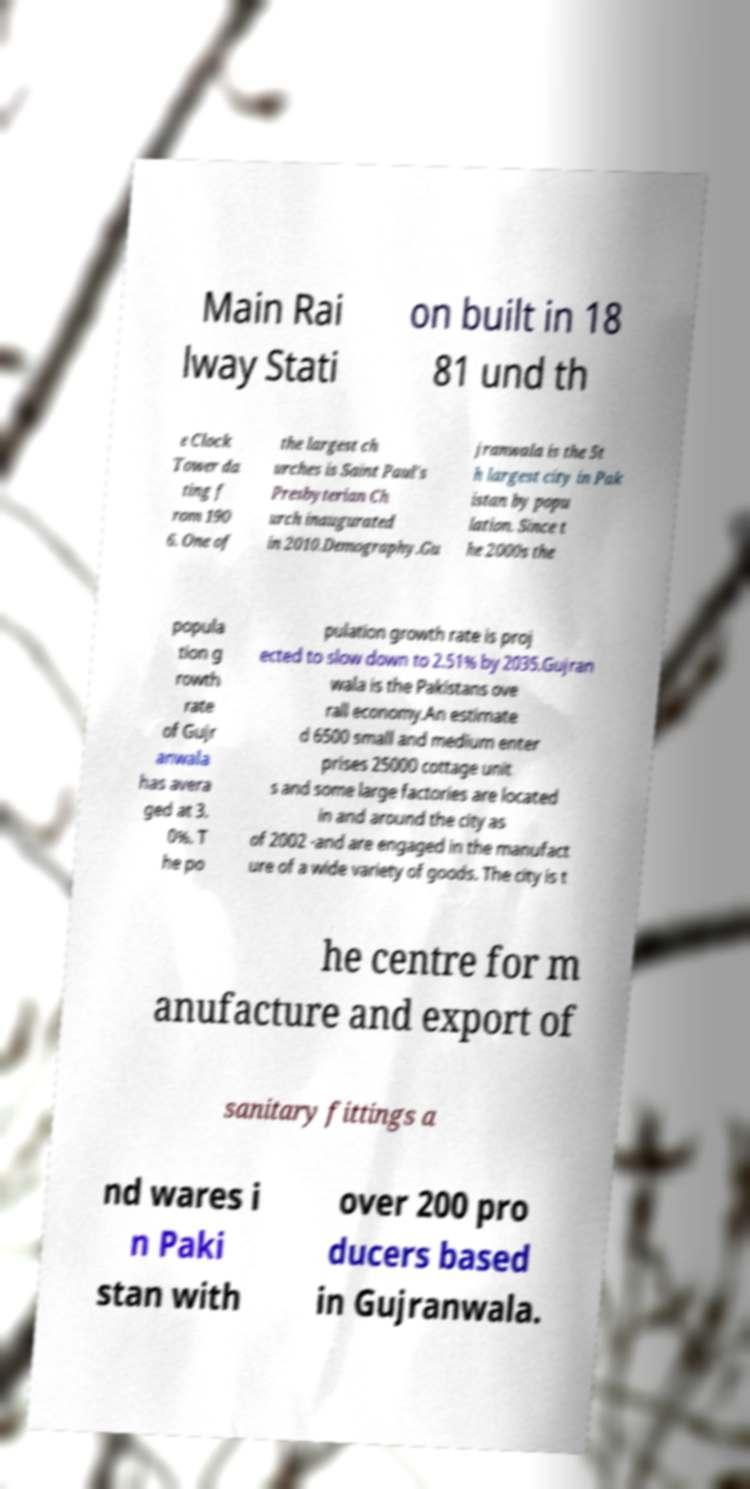Please read and relay the text visible in this image. What does it say? Main Rai lway Stati on built in 18 81 und th e Clock Tower da ting f rom 190 6. One of the largest ch urches is Saint Paul's Presbyterian Ch urch inaugurated in 2010.Demography.Gu jranwala is the 5t h largest city in Pak istan by popu lation. Since t he 2000s the popula tion g rowth rate of Gujr anwala has avera ged at 3. 0%. T he po pulation growth rate is proj ected to slow down to 2.51% by 2035.Gujran wala is the Pakistans ove rall economy.An estimate d 6500 small and medium enter prises 25000 cottage unit s and some large factories are located in and around the city as of 2002 -and are engaged in the manufact ure of a wide variety of goods. The city is t he centre for m anufacture and export of sanitary fittings a nd wares i n Paki stan with over 200 pro ducers based in Gujranwala. 